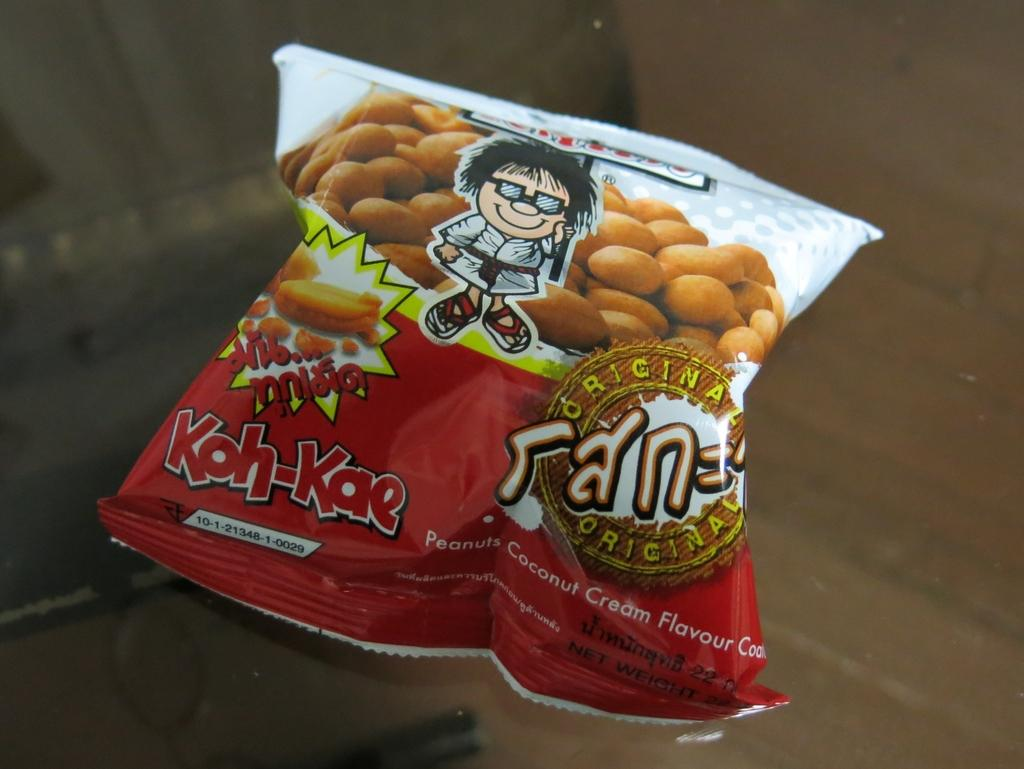What is the main object in the image? There is a food packet in the image. What can be seen on the food packet? The food packet has text on it and a cartoon image. How is the food packet positioned in the image? The food packet is placed on a glass. What type of toy is running across the food packet in the image? There is no toy present in the image, and no toy is running across the food packet. 